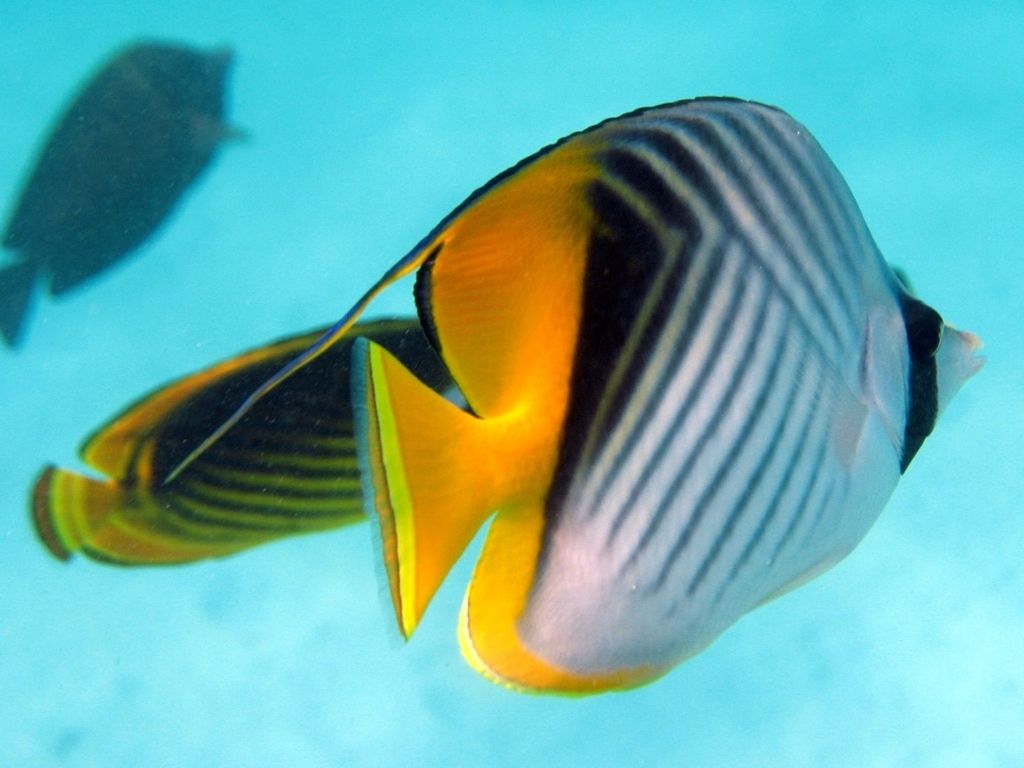Explore the quality factors of the image and offer an evaluation based on your insights. Upon examining the image, the photo's clarity is commendable, albeit with a slight presence of noise that is typical in underwater photography. The subject, a striking tropical fish, is captured with a compelling composition that augments its streamlined shape and delicate fin structure. The backdrop provides a soothing blue gradient that doesn't compete with the subject for attention but aids in conveying the serene underwater ambiance. Colors are indeed vibrant, capturing the essence of the marine life's vivid palette, from the golden yellow to the subtle striped patterning. The photograph successfully focuses attention on the fish through good use of depth of field, ensuring that the subject remains the focal point amidst its dynamic environment. Overall, the image is of high quality and serves as an excellent portrayal of aquatic biodiversity. 